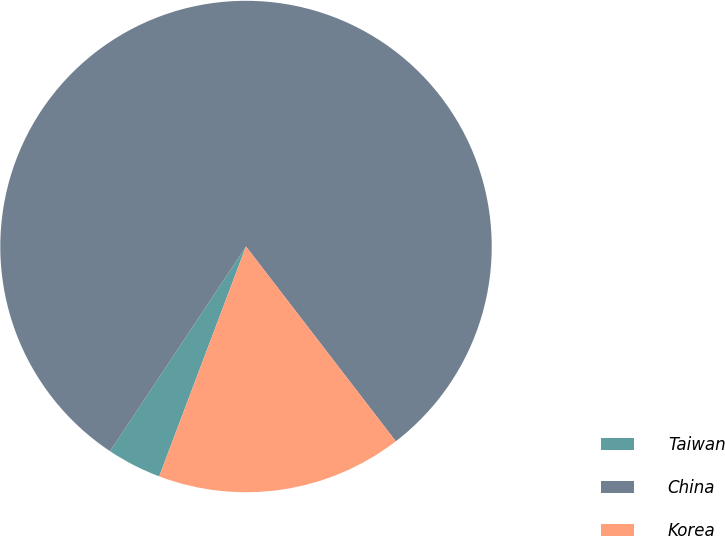Convert chart. <chart><loc_0><loc_0><loc_500><loc_500><pie_chart><fcel>Taiwan<fcel>China<fcel>Korea<nl><fcel>3.59%<fcel>80.23%<fcel>16.18%<nl></chart> 